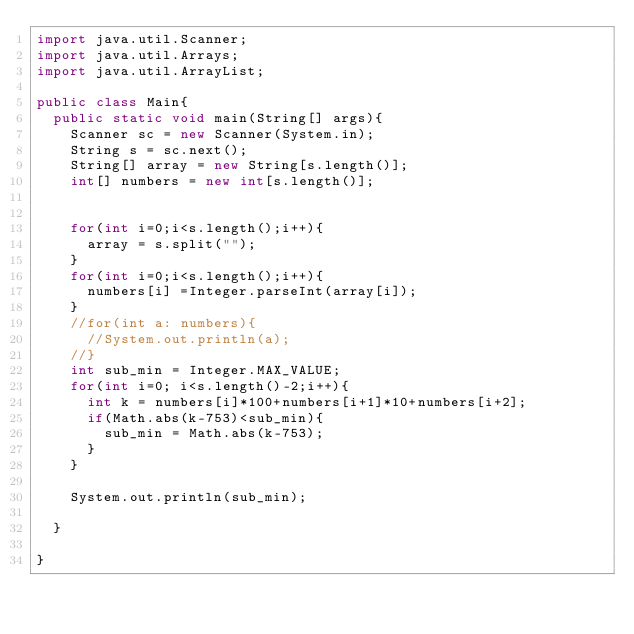<code> <loc_0><loc_0><loc_500><loc_500><_Java_>import java.util.Scanner;
import java.util.Arrays;
import java.util.ArrayList;

public class Main{
  public static void main(String[] args){
    Scanner sc = new Scanner(System.in);
    String s = sc.next();
    String[] array = new String[s.length()];
    int[] numbers = new int[s.length()];


    for(int i=0;i<s.length();i++){
      array = s.split("");
    }
    for(int i=0;i<s.length();i++){
      numbers[i] =Integer.parseInt(array[i]);
    }
    //for(int a: numbers){
      //System.out.println(a);
    //}
    int sub_min = Integer.MAX_VALUE;
    for(int i=0; i<s.length()-2;i++){
      int k = numbers[i]*100+numbers[i+1]*10+numbers[i+2];
      if(Math.abs(k-753)<sub_min){
        sub_min = Math.abs(k-753);
      }
    }

    System.out.println(sub_min);

  }

}</code> 